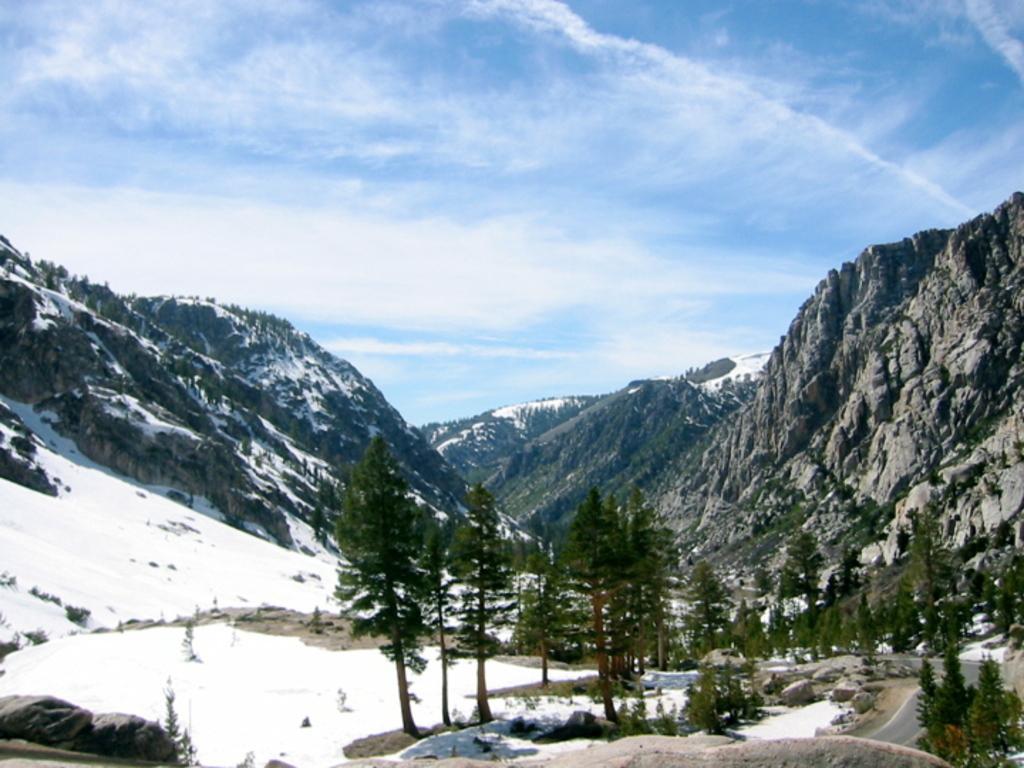Describe this image in one or two sentences. There are trees. Also on the left side there is snow on the ground. In the back there are hills. And in the background there is sky. 